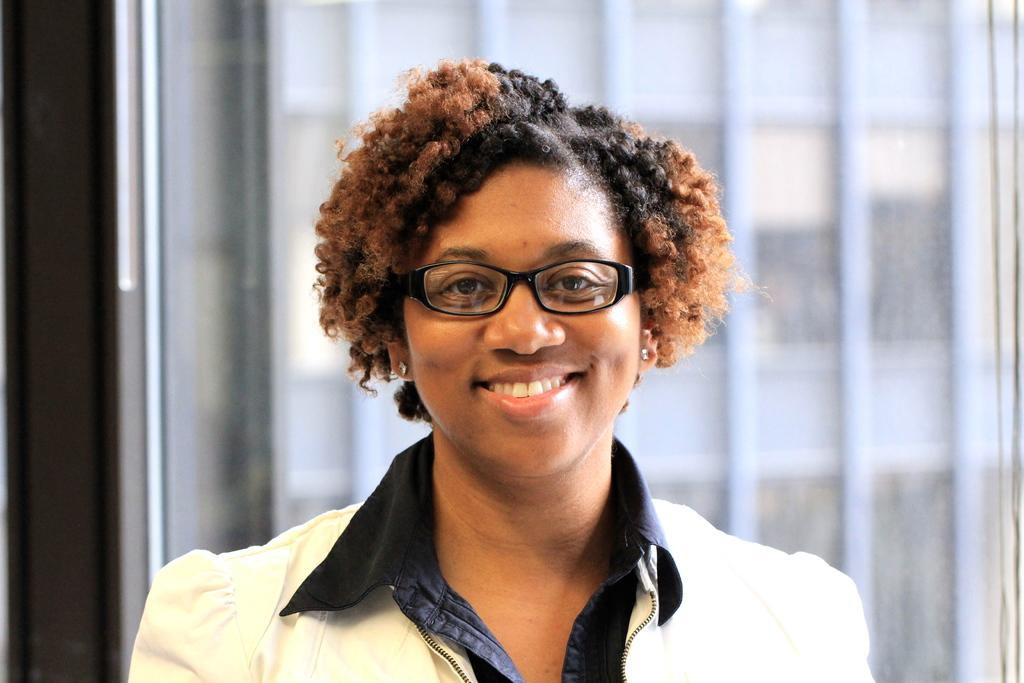Who is the main subject in the image? There is a woman in the image. What is the woman doing in the image? The woman is laughing. What is the woman wearing on her upper body? The woman is wearing a white coat. What accessory is the woman wearing on her face? The woman is wearing black spectacles. What type of marble is visible on the floor in the image? There is no marble visible on the floor in the image; it only features the woman. What kind of rail can be seen in the background of the image? There is no rail present in the image; it only features the woman. 